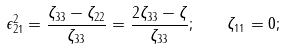<formula> <loc_0><loc_0><loc_500><loc_500>\epsilon _ { 2 1 } ^ { 2 } = \frac { \zeta _ { 3 3 } - \zeta _ { 2 2 } } { \zeta _ { 3 3 } } = \frac { 2 \zeta _ { 3 3 } - \zeta } { \zeta _ { 3 3 } } ; \quad \zeta _ { 1 1 } = 0 ;</formula> 